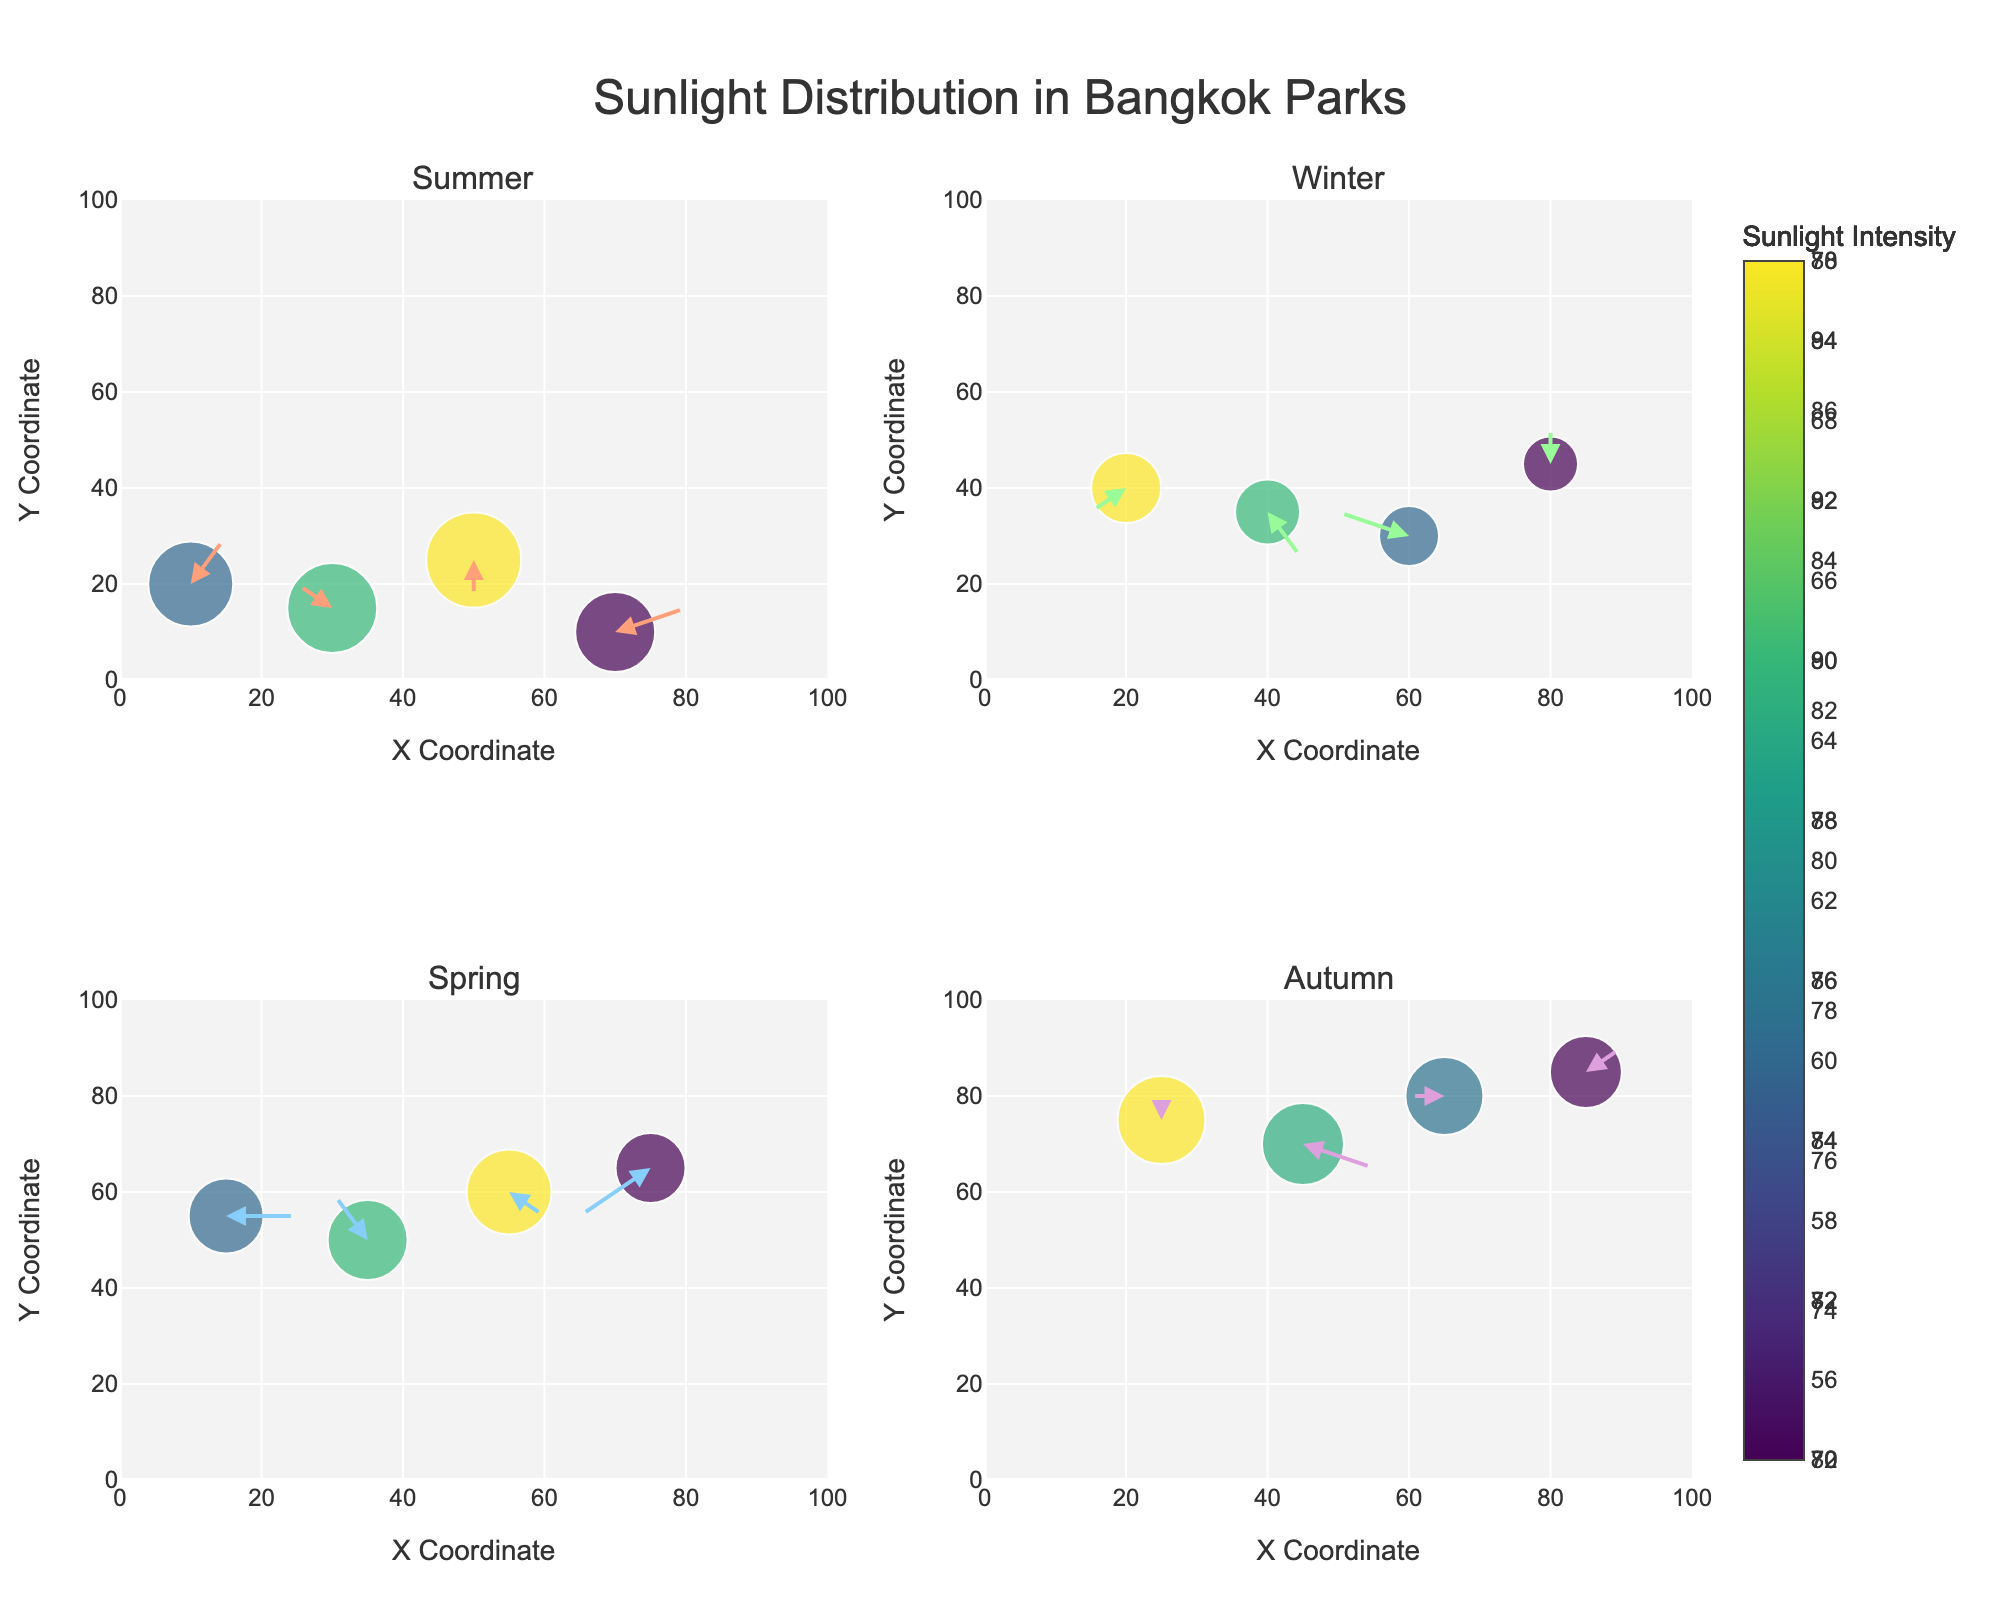What's the title of the figure? The title of the figure is usually found at the top, and it provides a summary of what the figure represents. In this case, the title is "Sunlight Distribution in Bangkok Parks".
Answer: Sunlight Distribution in Bangkok Parks How many seasons are represented in the figure? Look for labels or titles within the subplots; each subplot represents a season. There are four subplot titles, each corresponding to a different season.
Answer: Four Which season shows the highest sunlight intensity value? Look at the color scale for sunlight intensity, and find the highest value in each subplot. Summer shows the highest sunlight intensity, especially with the data point at (50, 25) having an intensity of 95.
Answer: Summer What is the direction of sunlight exposure for parks in the winter season? Examine the direction of the arrows in the subplot titled "Winter". Most arrows in the winter subplot are pointing in diverse directions but with a majority showing angles downward or downward-right.
Answer: Downward or downward-right How does the distribution pattern in Autumn compare to Spring? Observe the positions, directions, and intensities in the subplots titled "Autumn" and "Spring". Autumn has diversely scattered points with most arrows pointing in mixed directions, whereas Spring has points more centrally located with arrows also pointing in mixed directions but somewhat balanced.
Answer: Mixed directions, slightly denser in Spring In which season does the point (15, 55) show up, and what is its sunlight intensity? Find the coordinates (15, 55) in the subplots. In the Spring subplot, the coordinate (15, 55) has a sunlight intensity value of 75.
Answer: Spring, 75 What general trend do the quiver arrows indicate in the summer season? Check the direction and distribution of the arrows in the Summer subplot. Most arrows in Summer indicate upward or upward-right directions, signifying sunlight coming primarily from below.
Answer: Upward or upward-right Across all seasons, which season has the most southward (downward) arrows? Compare the directionality of the arrows across all subplots. Winter has the most downward direction arrows, indicating southward exposure.
Answer: Winter Which season has the least variability in sunlight intensity? Look at the color scale distribution within each subplot. Winter exhibits the least variability as the intensity values are closely packed within a smaller range.
Answer: Winter Where do the highest sunlight intensities typically fall on the figure in terms of X and Y coordinates? Identify coordinates with the darkest colors corresponding to the highest intensity values across all subplots. High intensities are generally seen in central coordinates such as around (50, 25) in Summer and (25, 75) in Autumn.
Answer: Central coordinates 